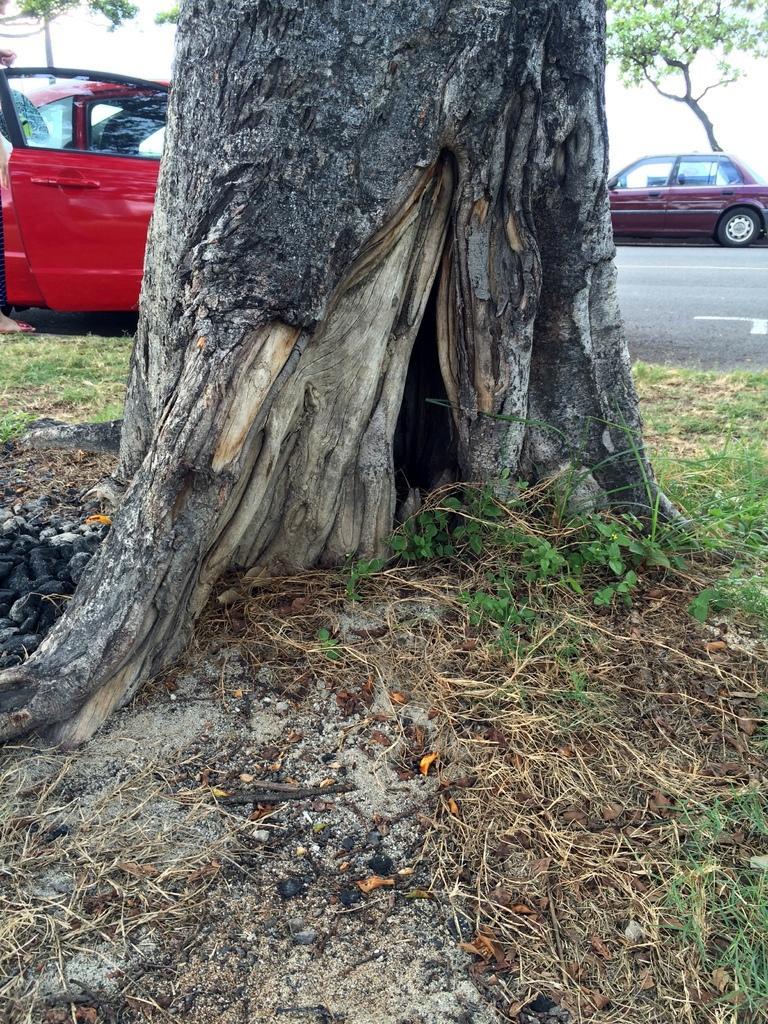Please provide a concise description of this image. In this picture we can see few plants, trees and cars, in the top left hand corner we can see a person. 